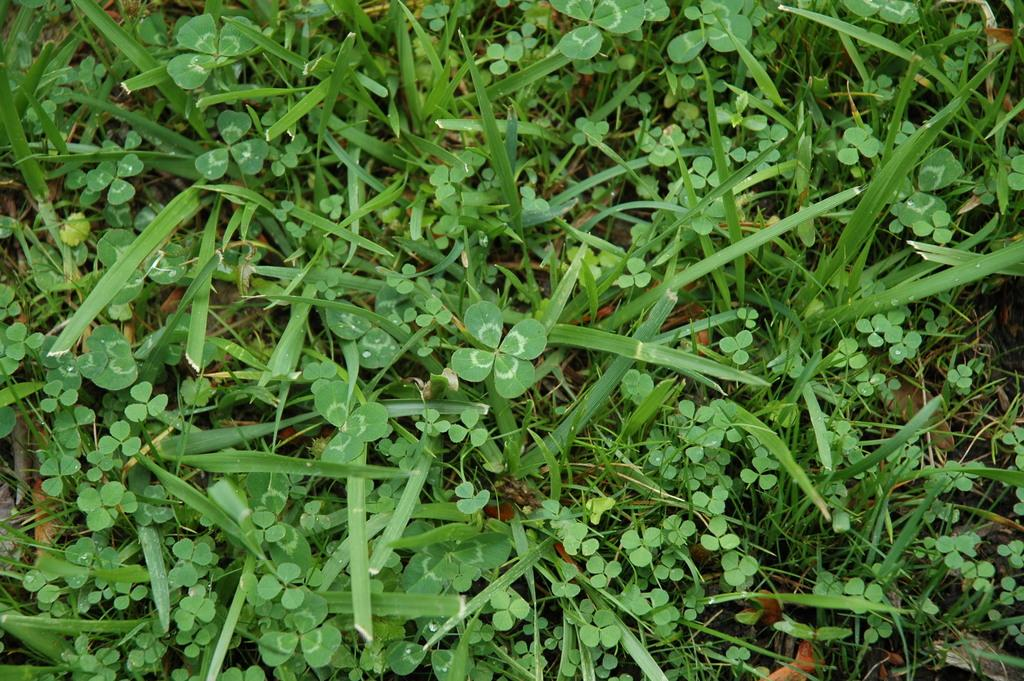What type of living organisms are in the image? There are small plants in the image. What color are the plants in the image? The plants are green in color. What type of whip can be seen being used on the plants in the image? There is no whip present in the image, and the plants are not being used on. What type of hope can be seen growing alongside the plants in the image? There is no reference to hope in the image; it features small green plants. 